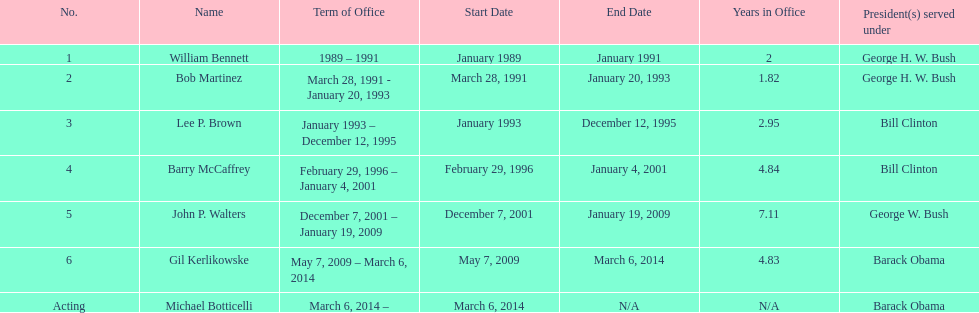Give me the full table as a dictionary. {'header': ['No.', 'Name', 'Term of Office', 'Start Date', 'End Date', 'Years in Office', 'President(s) served under'], 'rows': [['1', 'William Bennett', '1989 – 1991', 'January 1989', 'January 1991', '2', 'George H. W. Bush'], ['2', 'Bob Martinez', 'March 28, 1991 - January 20, 1993', 'March 28, 1991', 'January 20, 1993', '1.82', 'George H. W. Bush'], ['3', 'Lee P. Brown', 'January 1993 – December 12, 1995', 'January 1993', 'December 12, 1995', '2.95', 'Bill Clinton'], ['4', 'Barry McCaffrey', 'February 29, 1996 – January 4, 2001', 'February 29, 1996', 'January 4, 2001', '4.84', 'Bill Clinton'], ['5', 'John P. Walters', 'December 7, 2001 – January 19, 2009', 'December 7, 2001', 'January 19, 2009', '7.11', 'George W. Bush'], ['6', 'Gil Kerlikowske', 'May 7, 2009 – March 6, 2014', 'May 7, 2009', 'March 6, 2014', '4.83', 'Barack Obama'], ['Acting', 'Michael Botticelli', 'March 6, 2014 –', 'March 6, 2014', 'N/A', 'N/A', 'Barack Obama']]} How long did lee p. brown serve for? 2 years. 